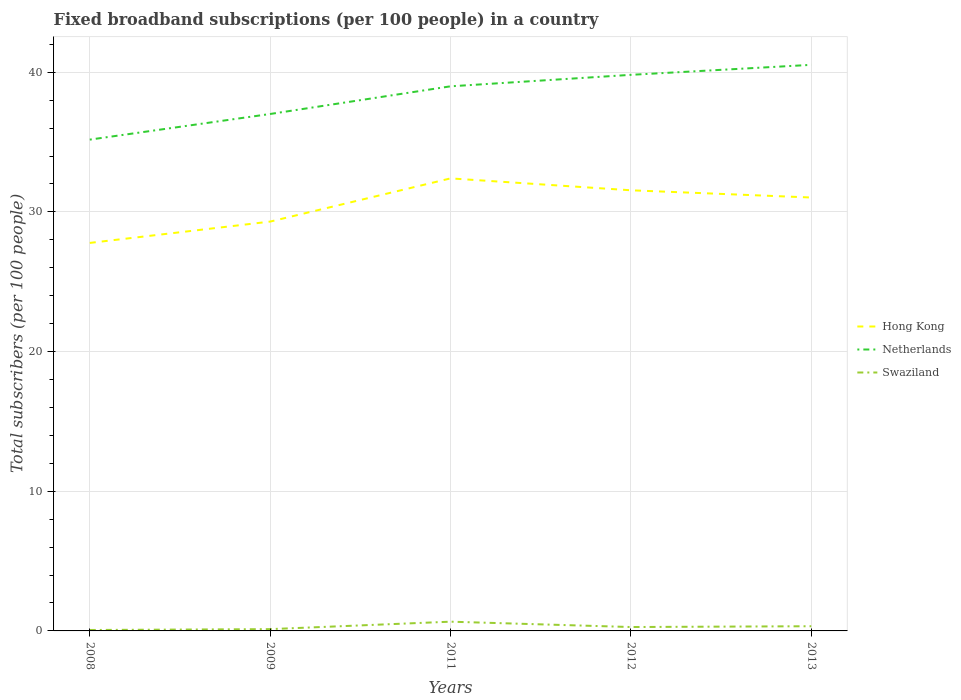Is the number of lines equal to the number of legend labels?
Offer a terse response. Yes. Across all years, what is the maximum number of broadband subscriptions in Hong Kong?
Give a very brief answer. 27.78. In which year was the number of broadband subscriptions in Hong Kong maximum?
Offer a very short reply. 2008. What is the total number of broadband subscriptions in Swaziland in the graph?
Make the answer very short. -0.6. What is the difference between the highest and the second highest number of broadband subscriptions in Swaziland?
Your answer should be very brief. 0.6. What is the difference between the highest and the lowest number of broadband subscriptions in Netherlands?
Offer a terse response. 3. How many lines are there?
Provide a short and direct response. 3. How many years are there in the graph?
Make the answer very short. 5. Are the values on the major ticks of Y-axis written in scientific E-notation?
Make the answer very short. No. Does the graph contain any zero values?
Make the answer very short. No. Where does the legend appear in the graph?
Your response must be concise. Center right. How are the legend labels stacked?
Give a very brief answer. Vertical. What is the title of the graph?
Your response must be concise. Fixed broadband subscriptions (per 100 people) in a country. Does "Australia" appear as one of the legend labels in the graph?
Make the answer very short. No. What is the label or title of the Y-axis?
Provide a short and direct response. Total subscribers (per 100 people). What is the Total subscribers (per 100 people) of Hong Kong in 2008?
Offer a very short reply. 27.78. What is the Total subscribers (per 100 people) in Netherlands in 2008?
Keep it short and to the point. 35.17. What is the Total subscribers (per 100 people) in Swaziland in 2008?
Make the answer very short. 0.07. What is the Total subscribers (per 100 people) in Hong Kong in 2009?
Make the answer very short. 29.3. What is the Total subscribers (per 100 people) in Netherlands in 2009?
Offer a very short reply. 37.01. What is the Total subscribers (per 100 people) of Swaziland in 2009?
Keep it short and to the point. 0.13. What is the Total subscribers (per 100 people) of Hong Kong in 2011?
Offer a very short reply. 32.4. What is the Total subscribers (per 100 people) of Netherlands in 2011?
Keep it short and to the point. 38.99. What is the Total subscribers (per 100 people) in Swaziland in 2011?
Keep it short and to the point. 0.66. What is the Total subscribers (per 100 people) in Hong Kong in 2012?
Provide a succinct answer. 31.55. What is the Total subscribers (per 100 people) in Netherlands in 2012?
Your response must be concise. 39.81. What is the Total subscribers (per 100 people) of Swaziland in 2012?
Your answer should be very brief. 0.28. What is the Total subscribers (per 100 people) in Hong Kong in 2013?
Your answer should be very brief. 31.03. What is the Total subscribers (per 100 people) in Netherlands in 2013?
Your answer should be compact. 40.53. What is the Total subscribers (per 100 people) in Swaziland in 2013?
Provide a succinct answer. 0.34. Across all years, what is the maximum Total subscribers (per 100 people) in Hong Kong?
Give a very brief answer. 32.4. Across all years, what is the maximum Total subscribers (per 100 people) of Netherlands?
Provide a short and direct response. 40.53. Across all years, what is the maximum Total subscribers (per 100 people) of Swaziland?
Make the answer very short. 0.66. Across all years, what is the minimum Total subscribers (per 100 people) of Hong Kong?
Offer a terse response. 27.78. Across all years, what is the minimum Total subscribers (per 100 people) in Netherlands?
Keep it short and to the point. 35.17. Across all years, what is the minimum Total subscribers (per 100 people) in Swaziland?
Provide a succinct answer. 0.07. What is the total Total subscribers (per 100 people) of Hong Kong in the graph?
Offer a very short reply. 152.05. What is the total Total subscribers (per 100 people) of Netherlands in the graph?
Your response must be concise. 191.51. What is the total Total subscribers (per 100 people) in Swaziland in the graph?
Make the answer very short. 1.47. What is the difference between the Total subscribers (per 100 people) in Hong Kong in 2008 and that in 2009?
Your answer should be compact. -1.53. What is the difference between the Total subscribers (per 100 people) in Netherlands in 2008 and that in 2009?
Offer a terse response. -1.84. What is the difference between the Total subscribers (per 100 people) of Swaziland in 2008 and that in 2009?
Offer a very short reply. -0.06. What is the difference between the Total subscribers (per 100 people) in Hong Kong in 2008 and that in 2011?
Keep it short and to the point. -4.62. What is the difference between the Total subscribers (per 100 people) in Netherlands in 2008 and that in 2011?
Give a very brief answer. -3.82. What is the difference between the Total subscribers (per 100 people) of Swaziland in 2008 and that in 2011?
Make the answer very short. -0.6. What is the difference between the Total subscribers (per 100 people) in Hong Kong in 2008 and that in 2012?
Offer a terse response. -3.77. What is the difference between the Total subscribers (per 100 people) of Netherlands in 2008 and that in 2012?
Give a very brief answer. -4.64. What is the difference between the Total subscribers (per 100 people) of Swaziland in 2008 and that in 2012?
Offer a very short reply. -0.21. What is the difference between the Total subscribers (per 100 people) in Hong Kong in 2008 and that in 2013?
Provide a succinct answer. -3.25. What is the difference between the Total subscribers (per 100 people) of Netherlands in 2008 and that in 2013?
Make the answer very short. -5.35. What is the difference between the Total subscribers (per 100 people) in Swaziland in 2008 and that in 2013?
Give a very brief answer. -0.27. What is the difference between the Total subscribers (per 100 people) of Hong Kong in 2009 and that in 2011?
Offer a very short reply. -3.09. What is the difference between the Total subscribers (per 100 people) in Netherlands in 2009 and that in 2011?
Provide a succinct answer. -1.98. What is the difference between the Total subscribers (per 100 people) of Swaziland in 2009 and that in 2011?
Make the answer very short. -0.53. What is the difference between the Total subscribers (per 100 people) of Hong Kong in 2009 and that in 2012?
Your answer should be very brief. -2.24. What is the difference between the Total subscribers (per 100 people) of Netherlands in 2009 and that in 2012?
Provide a short and direct response. -2.8. What is the difference between the Total subscribers (per 100 people) in Swaziland in 2009 and that in 2012?
Give a very brief answer. -0.15. What is the difference between the Total subscribers (per 100 people) of Hong Kong in 2009 and that in 2013?
Provide a succinct answer. -1.72. What is the difference between the Total subscribers (per 100 people) in Netherlands in 2009 and that in 2013?
Provide a succinct answer. -3.52. What is the difference between the Total subscribers (per 100 people) of Swaziland in 2009 and that in 2013?
Your response must be concise. -0.21. What is the difference between the Total subscribers (per 100 people) in Hong Kong in 2011 and that in 2012?
Provide a succinct answer. 0.85. What is the difference between the Total subscribers (per 100 people) in Netherlands in 2011 and that in 2012?
Make the answer very short. -0.82. What is the difference between the Total subscribers (per 100 people) of Swaziland in 2011 and that in 2012?
Provide a short and direct response. 0.38. What is the difference between the Total subscribers (per 100 people) of Hong Kong in 2011 and that in 2013?
Your answer should be very brief. 1.37. What is the difference between the Total subscribers (per 100 people) in Netherlands in 2011 and that in 2013?
Keep it short and to the point. -1.54. What is the difference between the Total subscribers (per 100 people) in Swaziland in 2011 and that in 2013?
Your answer should be compact. 0.33. What is the difference between the Total subscribers (per 100 people) of Hong Kong in 2012 and that in 2013?
Offer a very short reply. 0.52. What is the difference between the Total subscribers (per 100 people) in Netherlands in 2012 and that in 2013?
Your response must be concise. -0.72. What is the difference between the Total subscribers (per 100 people) in Swaziland in 2012 and that in 2013?
Offer a very short reply. -0.06. What is the difference between the Total subscribers (per 100 people) in Hong Kong in 2008 and the Total subscribers (per 100 people) in Netherlands in 2009?
Give a very brief answer. -9.23. What is the difference between the Total subscribers (per 100 people) of Hong Kong in 2008 and the Total subscribers (per 100 people) of Swaziland in 2009?
Your answer should be very brief. 27.65. What is the difference between the Total subscribers (per 100 people) in Netherlands in 2008 and the Total subscribers (per 100 people) in Swaziland in 2009?
Provide a succinct answer. 35.04. What is the difference between the Total subscribers (per 100 people) of Hong Kong in 2008 and the Total subscribers (per 100 people) of Netherlands in 2011?
Make the answer very short. -11.21. What is the difference between the Total subscribers (per 100 people) in Hong Kong in 2008 and the Total subscribers (per 100 people) in Swaziland in 2011?
Your response must be concise. 27.12. What is the difference between the Total subscribers (per 100 people) in Netherlands in 2008 and the Total subscribers (per 100 people) in Swaziland in 2011?
Offer a very short reply. 34.51. What is the difference between the Total subscribers (per 100 people) in Hong Kong in 2008 and the Total subscribers (per 100 people) in Netherlands in 2012?
Make the answer very short. -12.03. What is the difference between the Total subscribers (per 100 people) of Hong Kong in 2008 and the Total subscribers (per 100 people) of Swaziland in 2012?
Provide a short and direct response. 27.5. What is the difference between the Total subscribers (per 100 people) of Netherlands in 2008 and the Total subscribers (per 100 people) of Swaziland in 2012?
Your answer should be compact. 34.89. What is the difference between the Total subscribers (per 100 people) in Hong Kong in 2008 and the Total subscribers (per 100 people) in Netherlands in 2013?
Provide a succinct answer. -12.75. What is the difference between the Total subscribers (per 100 people) of Hong Kong in 2008 and the Total subscribers (per 100 people) of Swaziland in 2013?
Offer a terse response. 27.44. What is the difference between the Total subscribers (per 100 people) of Netherlands in 2008 and the Total subscribers (per 100 people) of Swaziland in 2013?
Your response must be concise. 34.84. What is the difference between the Total subscribers (per 100 people) in Hong Kong in 2009 and the Total subscribers (per 100 people) in Netherlands in 2011?
Your answer should be very brief. -9.68. What is the difference between the Total subscribers (per 100 people) in Hong Kong in 2009 and the Total subscribers (per 100 people) in Swaziland in 2011?
Provide a succinct answer. 28.64. What is the difference between the Total subscribers (per 100 people) in Netherlands in 2009 and the Total subscribers (per 100 people) in Swaziland in 2011?
Provide a succinct answer. 36.35. What is the difference between the Total subscribers (per 100 people) of Hong Kong in 2009 and the Total subscribers (per 100 people) of Netherlands in 2012?
Make the answer very short. -10.51. What is the difference between the Total subscribers (per 100 people) of Hong Kong in 2009 and the Total subscribers (per 100 people) of Swaziland in 2012?
Keep it short and to the point. 29.03. What is the difference between the Total subscribers (per 100 people) in Netherlands in 2009 and the Total subscribers (per 100 people) in Swaziland in 2012?
Your response must be concise. 36.73. What is the difference between the Total subscribers (per 100 people) in Hong Kong in 2009 and the Total subscribers (per 100 people) in Netherlands in 2013?
Provide a short and direct response. -11.22. What is the difference between the Total subscribers (per 100 people) of Hong Kong in 2009 and the Total subscribers (per 100 people) of Swaziland in 2013?
Make the answer very short. 28.97. What is the difference between the Total subscribers (per 100 people) of Netherlands in 2009 and the Total subscribers (per 100 people) of Swaziland in 2013?
Keep it short and to the point. 36.67. What is the difference between the Total subscribers (per 100 people) of Hong Kong in 2011 and the Total subscribers (per 100 people) of Netherlands in 2012?
Ensure brevity in your answer.  -7.41. What is the difference between the Total subscribers (per 100 people) in Hong Kong in 2011 and the Total subscribers (per 100 people) in Swaziland in 2012?
Your response must be concise. 32.12. What is the difference between the Total subscribers (per 100 people) in Netherlands in 2011 and the Total subscribers (per 100 people) in Swaziland in 2012?
Give a very brief answer. 38.71. What is the difference between the Total subscribers (per 100 people) of Hong Kong in 2011 and the Total subscribers (per 100 people) of Netherlands in 2013?
Offer a terse response. -8.13. What is the difference between the Total subscribers (per 100 people) of Hong Kong in 2011 and the Total subscribers (per 100 people) of Swaziland in 2013?
Your answer should be very brief. 32.06. What is the difference between the Total subscribers (per 100 people) in Netherlands in 2011 and the Total subscribers (per 100 people) in Swaziland in 2013?
Offer a very short reply. 38.65. What is the difference between the Total subscribers (per 100 people) in Hong Kong in 2012 and the Total subscribers (per 100 people) in Netherlands in 2013?
Your response must be concise. -8.98. What is the difference between the Total subscribers (per 100 people) in Hong Kong in 2012 and the Total subscribers (per 100 people) in Swaziland in 2013?
Keep it short and to the point. 31.21. What is the difference between the Total subscribers (per 100 people) in Netherlands in 2012 and the Total subscribers (per 100 people) in Swaziland in 2013?
Provide a succinct answer. 39.47. What is the average Total subscribers (per 100 people) of Hong Kong per year?
Your answer should be very brief. 30.41. What is the average Total subscribers (per 100 people) in Netherlands per year?
Keep it short and to the point. 38.3. What is the average Total subscribers (per 100 people) in Swaziland per year?
Your response must be concise. 0.29. In the year 2008, what is the difference between the Total subscribers (per 100 people) in Hong Kong and Total subscribers (per 100 people) in Netherlands?
Your response must be concise. -7.4. In the year 2008, what is the difference between the Total subscribers (per 100 people) in Hong Kong and Total subscribers (per 100 people) in Swaziland?
Make the answer very short. 27.71. In the year 2008, what is the difference between the Total subscribers (per 100 people) in Netherlands and Total subscribers (per 100 people) in Swaziland?
Ensure brevity in your answer.  35.11. In the year 2009, what is the difference between the Total subscribers (per 100 people) in Hong Kong and Total subscribers (per 100 people) in Netherlands?
Your answer should be compact. -7.7. In the year 2009, what is the difference between the Total subscribers (per 100 people) in Hong Kong and Total subscribers (per 100 people) in Swaziland?
Your answer should be very brief. 29.18. In the year 2009, what is the difference between the Total subscribers (per 100 people) in Netherlands and Total subscribers (per 100 people) in Swaziland?
Provide a succinct answer. 36.88. In the year 2011, what is the difference between the Total subscribers (per 100 people) of Hong Kong and Total subscribers (per 100 people) of Netherlands?
Your answer should be compact. -6.59. In the year 2011, what is the difference between the Total subscribers (per 100 people) in Hong Kong and Total subscribers (per 100 people) in Swaziland?
Keep it short and to the point. 31.73. In the year 2011, what is the difference between the Total subscribers (per 100 people) in Netherlands and Total subscribers (per 100 people) in Swaziland?
Ensure brevity in your answer.  38.33. In the year 2012, what is the difference between the Total subscribers (per 100 people) in Hong Kong and Total subscribers (per 100 people) in Netherlands?
Make the answer very short. -8.27. In the year 2012, what is the difference between the Total subscribers (per 100 people) in Hong Kong and Total subscribers (per 100 people) in Swaziland?
Offer a terse response. 31.27. In the year 2012, what is the difference between the Total subscribers (per 100 people) of Netherlands and Total subscribers (per 100 people) of Swaziland?
Your answer should be compact. 39.53. In the year 2013, what is the difference between the Total subscribers (per 100 people) in Hong Kong and Total subscribers (per 100 people) in Netherlands?
Your answer should be very brief. -9.5. In the year 2013, what is the difference between the Total subscribers (per 100 people) in Hong Kong and Total subscribers (per 100 people) in Swaziland?
Offer a terse response. 30.69. In the year 2013, what is the difference between the Total subscribers (per 100 people) of Netherlands and Total subscribers (per 100 people) of Swaziland?
Your answer should be compact. 40.19. What is the ratio of the Total subscribers (per 100 people) of Hong Kong in 2008 to that in 2009?
Ensure brevity in your answer.  0.95. What is the ratio of the Total subscribers (per 100 people) of Netherlands in 2008 to that in 2009?
Your answer should be compact. 0.95. What is the ratio of the Total subscribers (per 100 people) of Swaziland in 2008 to that in 2009?
Provide a succinct answer. 0.52. What is the ratio of the Total subscribers (per 100 people) in Hong Kong in 2008 to that in 2011?
Provide a short and direct response. 0.86. What is the ratio of the Total subscribers (per 100 people) in Netherlands in 2008 to that in 2011?
Your answer should be very brief. 0.9. What is the ratio of the Total subscribers (per 100 people) in Swaziland in 2008 to that in 2011?
Ensure brevity in your answer.  0.1. What is the ratio of the Total subscribers (per 100 people) of Hong Kong in 2008 to that in 2012?
Your answer should be very brief. 0.88. What is the ratio of the Total subscribers (per 100 people) in Netherlands in 2008 to that in 2012?
Keep it short and to the point. 0.88. What is the ratio of the Total subscribers (per 100 people) in Swaziland in 2008 to that in 2012?
Keep it short and to the point. 0.24. What is the ratio of the Total subscribers (per 100 people) in Hong Kong in 2008 to that in 2013?
Provide a succinct answer. 0.9. What is the ratio of the Total subscribers (per 100 people) of Netherlands in 2008 to that in 2013?
Offer a terse response. 0.87. What is the ratio of the Total subscribers (per 100 people) of Swaziland in 2008 to that in 2013?
Offer a very short reply. 0.2. What is the ratio of the Total subscribers (per 100 people) in Hong Kong in 2009 to that in 2011?
Your answer should be very brief. 0.9. What is the ratio of the Total subscribers (per 100 people) in Netherlands in 2009 to that in 2011?
Offer a terse response. 0.95. What is the ratio of the Total subscribers (per 100 people) of Swaziland in 2009 to that in 2011?
Ensure brevity in your answer.  0.19. What is the ratio of the Total subscribers (per 100 people) in Hong Kong in 2009 to that in 2012?
Offer a terse response. 0.93. What is the ratio of the Total subscribers (per 100 people) of Netherlands in 2009 to that in 2012?
Keep it short and to the point. 0.93. What is the ratio of the Total subscribers (per 100 people) in Swaziland in 2009 to that in 2012?
Provide a succinct answer. 0.46. What is the ratio of the Total subscribers (per 100 people) of Hong Kong in 2009 to that in 2013?
Offer a very short reply. 0.94. What is the ratio of the Total subscribers (per 100 people) of Netherlands in 2009 to that in 2013?
Offer a very short reply. 0.91. What is the ratio of the Total subscribers (per 100 people) of Swaziland in 2009 to that in 2013?
Make the answer very short. 0.38. What is the ratio of the Total subscribers (per 100 people) in Hong Kong in 2011 to that in 2012?
Offer a very short reply. 1.03. What is the ratio of the Total subscribers (per 100 people) in Netherlands in 2011 to that in 2012?
Ensure brevity in your answer.  0.98. What is the ratio of the Total subscribers (per 100 people) in Swaziland in 2011 to that in 2012?
Make the answer very short. 2.38. What is the ratio of the Total subscribers (per 100 people) in Hong Kong in 2011 to that in 2013?
Your response must be concise. 1.04. What is the ratio of the Total subscribers (per 100 people) of Netherlands in 2011 to that in 2013?
Give a very brief answer. 0.96. What is the ratio of the Total subscribers (per 100 people) in Swaziland in 2011 to that in 2013?
Your answer should be compact. 1.97. What is the ratio of the Total subscribers (per 100 people) of Hong Kong in 2012 to that in 2013?
Offer a terse response. 1.02. What is the ratio of the Total subscribers (per 100 people) in Netherlands in 2012 to that in 2013?
Give a very brief answer. 0.98. What is the ratio of the Total subscribers (per 100 people) in Swaziland in 2012 to that in 2013?
Your response must be concise. 0.83. What is the difference between the highest and the second highest Total subscribers (per 100 people) in Hong Kong?
Make the answer very short. 0.85. What is the difference between the highest and the second highest Total subscribers (per 100 people) in Netherlands?
Offer a very short reply. 0.72. What is the difference between the highest and the second highest Total subscribers (per 100 people) of Swaziland?
Give a very brief answer. 0.33. What is the difference between the highest and the lowest Total subscribers (per 100 people) in Hong Kong?
Provide a succinct answer. 4.62. What is the difference between the highest and the lowest Total subscribers (per 100 people) of Netherlands?
Offer a very short reply. 5.35. What is the difference between the highest and the lowest Total subscribers (per 100 people) in Swaziland?
Your answer should be compact. 0.6. 